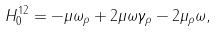<formula> <loc_0><loc_0><loc_500><loc_500>H _ { 0 } ^ { 1 2 } = - \mu \omega _ { \rho } + 2 \mu \omega \gamma _ { \rho } - 2 \mu _ { \rho } \omega ,</formula> 